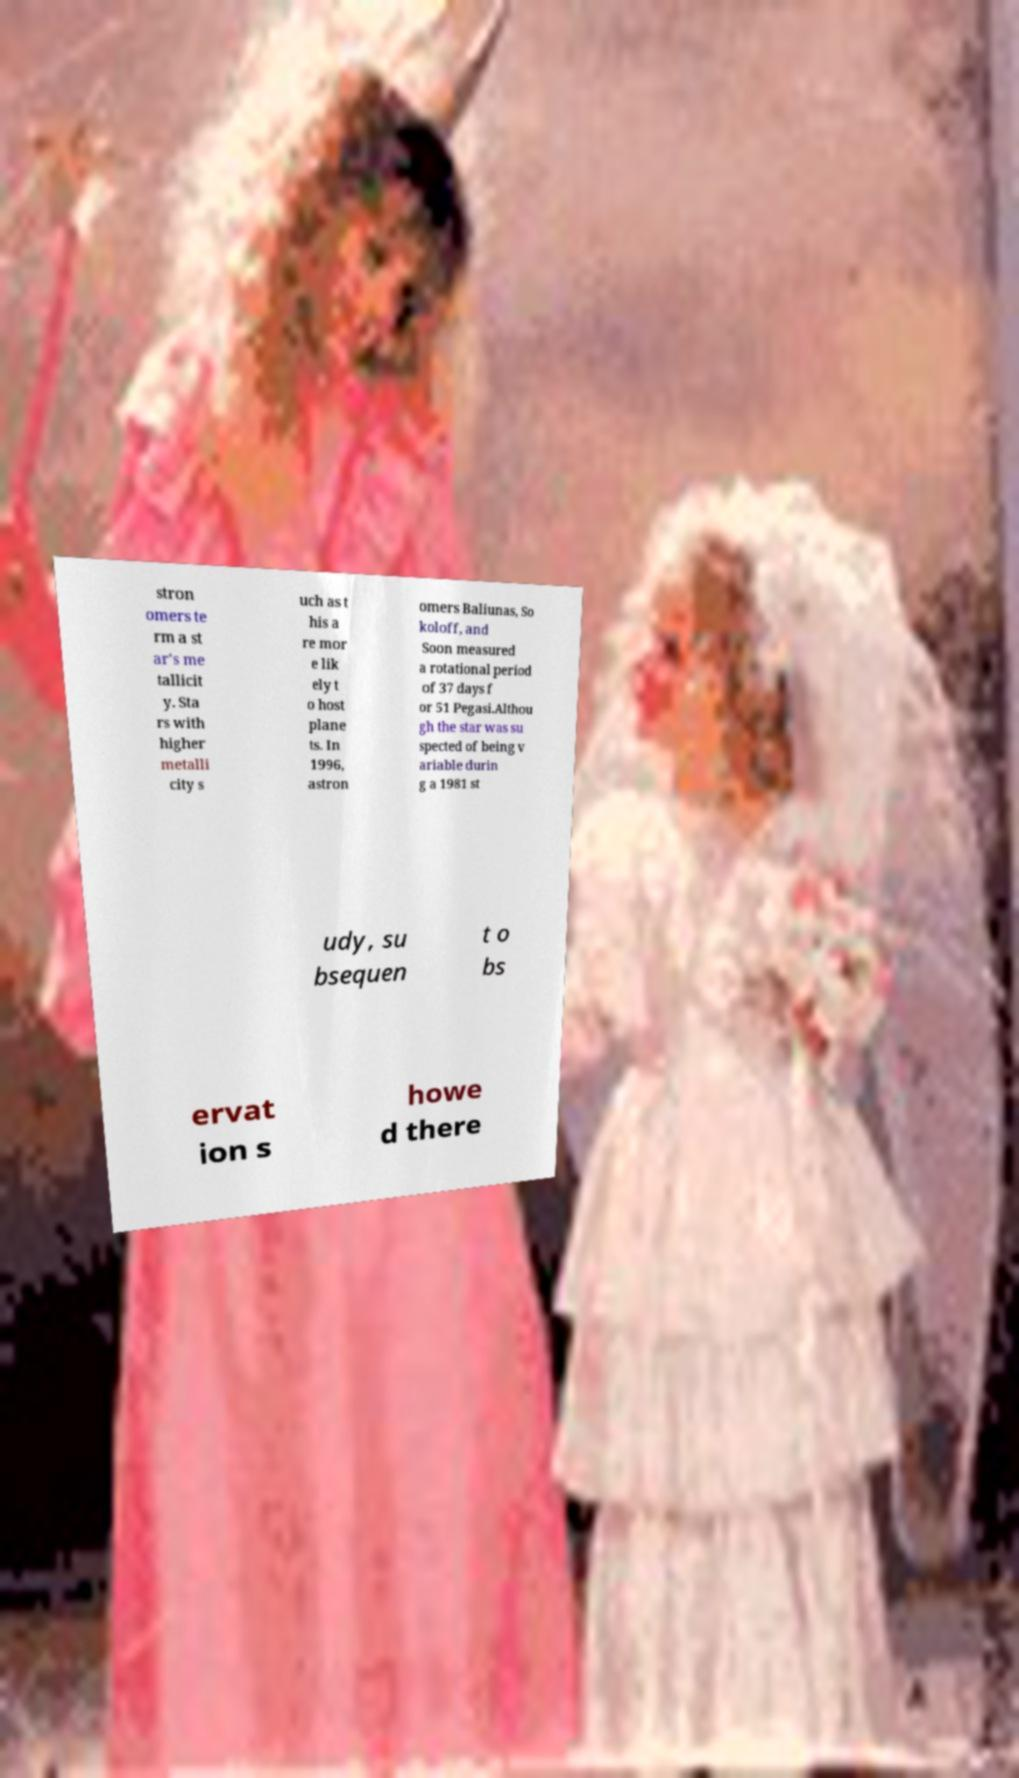Please read and relay the text visible in this image. What does it say? stron omers te rm a st ar's me tallicit y. Sta rs with higher metalli city s uch as t his a re mor e lik ely t o host plane ts. In 1996, astron omers Baliunas, So koloff, and Soon measured a rotational period of 37 days f or 51 Pegasi.Althou gh the star was su spected of being v ariable durin g a 1981 st udy, su bsequen t o bs ervat ion s howe d there 